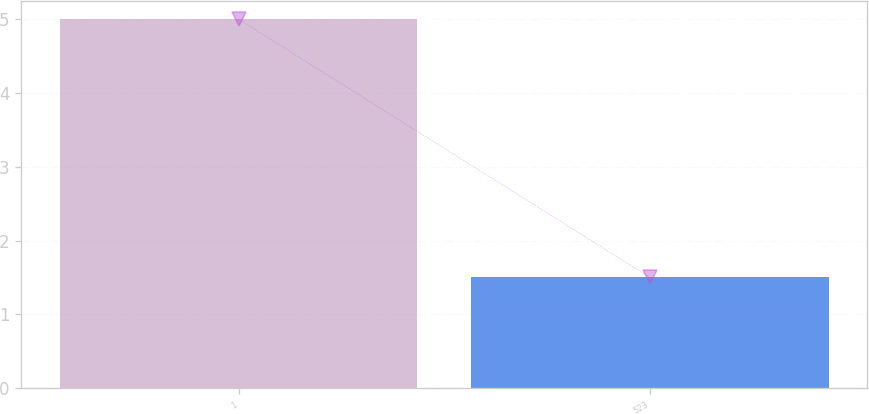Convert chart. <chart><loc_0><loc_0><loc_500><loc_500><bar_chart><fcel>1<fcel>523<nl><fcel>5<fcel>1.5<nl></chart> 